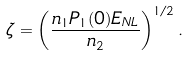Convert formula to latex. <formula><loc_0><loc_0><loc_500><loc_500>\zeta = \left ( \frac { n _ { 1 } P _ { 1 } ( 0 ) E _ { N L } } { n _ { 2 } } \right ) ^ { 1 / 2 } .</formula> 